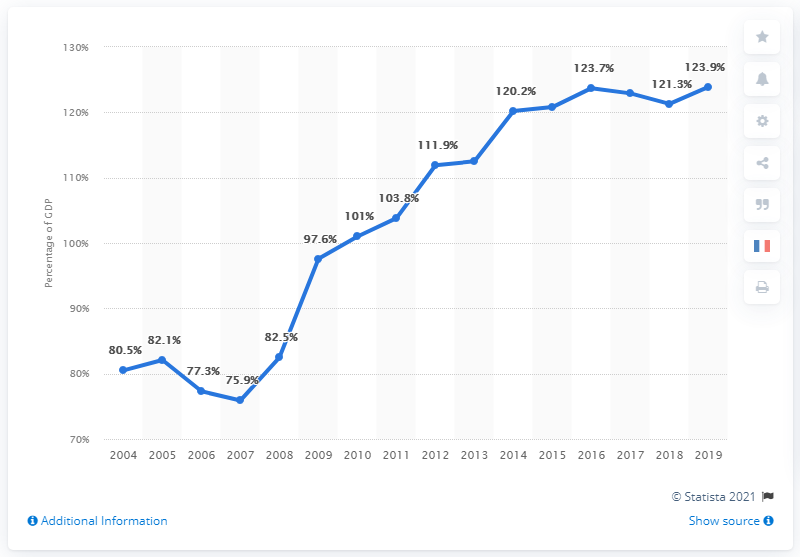Give some essential details in this illustration. The graph is increasing. The difference between the lowest GDP and the median is 27.9. 